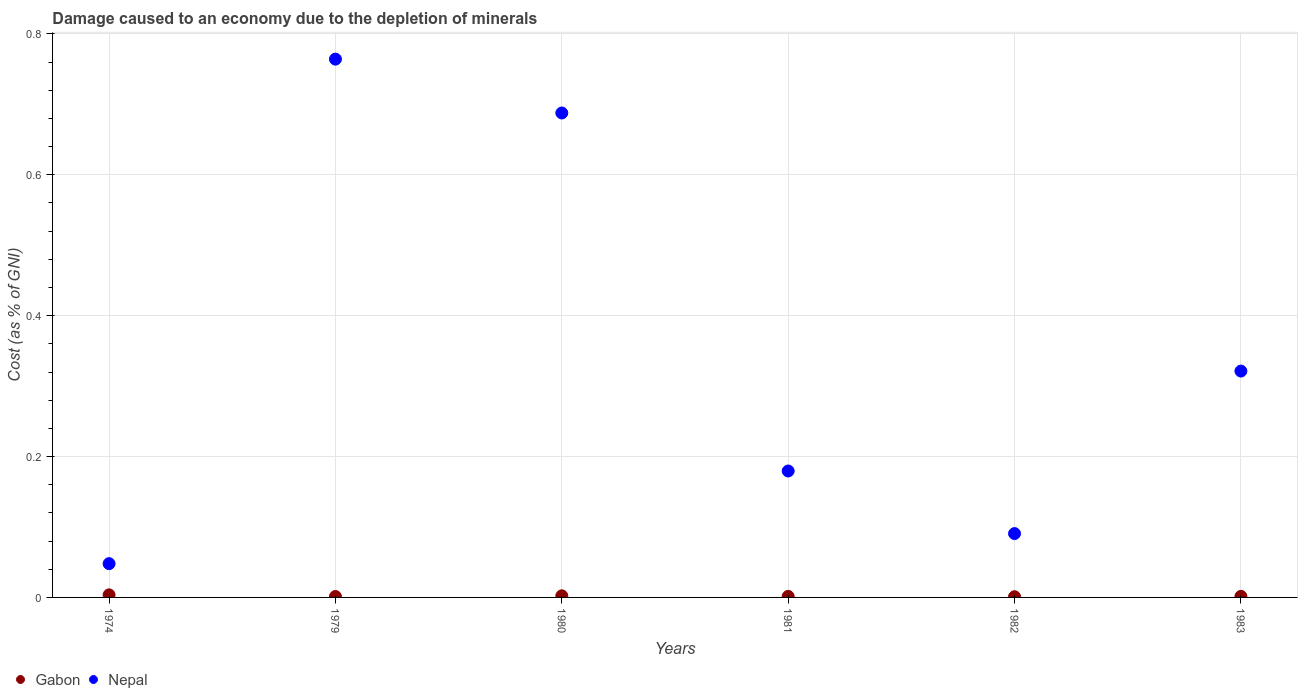How many different coloured dotlines are there?
Your answer should be very brief. 2. Is the number of dotlines equal to the number of legend labels?
Your response must be concise. Yes. What is the cost of damage caused due to the depletion of minerals in Gabon in 1980?
Provide a short and direct response. 0. Across all years, what is the maximum cost of damage caused due to the depletion of minerals in Nepal?
Give a very brief answer. 0.76. Across all years, what is the minimum cost of damage caused due to the depletion of minerals in Nepal?
Your answer should be compact. 0.05. In which year was the cost of damage caused due to the depletion of minerals in Nepal maximum?
Offer a terse response. 1979. In which year was the cost of damage caused due to the depletion of minerals in Nepal minimum?
Keep it short and to the point. 1974. What is the total cost of damage caused due to the depletion of minerals in Gabon in the graph?
Keep it short and to the point. 0.01. What is the difference between the cost of damage caused due to the depletion of minerals in Nepal in 1982 and that in 1983?
Make the answer very short. -0.23. What is the difference between the cost of damage caused due to the depletion of minerals in Gabon in 1981 and the cost of damage caused due to the depletion of minerals in Nepal in 1980?
Keep it short and to the point. -0.69. What is the average cost of damage caused due to the depletion of minerals in Nepal per year?
Keep it short and to the point. 0.35. In the year 1974, what is the difference between the cost of damage caused due to the depletion of minerals in Nepal and cost of damage caused due to the depletion of minerals in Gabon?
Your answer should be compact. 0.04. In how many years, is the cost of damage caused due to the depletion of minerals in Gabon greater than 0.7600000000000001 %?
Provide a succinct answer. 0. What is the ratio of the cost of damage caused due to the depletion of minerals in Nepal in 1974 to that in 1981?
Offer a very short reply. 0.27. Is the cost of damage caused due to the depletion of minerals in Nepal in 1974 less than that in 1981?
Ensure brevity in your answer.  Yes. What is the difference between the highest and the second highest cost of damage caused due to the depletion of minerals in Nepal?
Offer a terse response. 0.08. What is the difference between the highest and the lowest cost of damage caused due to the depletion of minerals in Gabon?
Keep it short and to the point. 0. Is the sum of the cost of damage caused due to the depletion of minerals in Gabon in 1981 and 1983 greater than the maximum cost of damage caused due to the depletion of minerals in Nepal across all years?
Make the answer very short. No. Does the cost of damage caused due to the depletion of minerals in Gabon monotonically increase over the years?
Offer a very short reply. No. How many years are there in the graph?
Provide a short and direct response. 6. Does the graph contain any zero values?
Provide a succinct answer. No. How many legend labels are there?
Offer a terse response. 2. How are the legend labels stacked?
Make the answer very short. Horizontal. What is the title of the graph?
Keep it short and to the point. Damage caused to an economy due to the depletion of minerals. What is the label or title of the X-axis?
Ensure brevity in your answer.  Years. What is the label or title of the Y-axis?
Your answer should be very brief. Cost (as % of GNI). What is the Cost (as % of GNI) of Gabon in 1974?
Provide a short and direct response. 0. What is the Cost (as % of GNI) of Nepal in 1974?
Your answer should be very brief. 0.05. What is the Cost (as % of GNI) in Gabon in 1979?
Ensure brevity in your answer.  0. What is the Cost (as % of GNI) in Nepal in 1979?
Make the answer very short. 0.76. What is the Cost (as % of GNI) in Gabon in 1980?
Provide a succinct answer. 0. What is the Cost (as % of GNI) in Nepal in 1980?
Give a very brief answer. 0.69. What is the Cost (as % of GNI) of Gabon in 1981?
Make the answer very short. 0. What is the Cost (as % of GNI) in Nepal in 1981?
Offer a very short reply. 0.18. What is the Cost (as % of GNI) of Gabon in 1982?
Make the answer very short. 0. What is the Cost (as % of GNI) in Nepal in 1982?
Your answer should be very brief. 0.09. What is the Cost (as % of GNI) in Gabon in 1983?
Your response must be concise. 0. What is the Cost (as % of GNI) of Nepal in 1983?
Make the answer very short. 0.32. Across all years, what is the maximum Cost (as % of GNI) in Gabon?
Your response must be concise. 0. Across all years, what is the maximum Cost (as % of GNI) of Nepal?
Make the answer very short. 0.76. Across all years, what is the minimum Cost (as % of GNI) in Gabon?
Your answer should be very brief. 0. Across all years, what is the minimum Cost (as % of GNI) of Nepal?
Offer a terse response. 0.05. What is the total Cost (as % of GNI) in Gabon in the graph?
Provide a short and direct response. 0.01. What is the total Cost (as % of GNI) of Nepal in the graph?
Provide a short and direct response. 2.09. What is the difference between the Cost (as % of GNI) in Gabon in 1974 and that in 1979?
Offer a terse response. 0. What is the difference between the Cost (as % of GNI) of Nepal in 1974 and that in 1979?
Your answer should be very brief. -0.72. What is the difference between the Cost (as % of GNI) of Gabon in 1974 and that in 1980?
Make the answer very short. 0. What is the difference between the Cost (as % of GNI) of Nepal in 1974 and that in 1980?
Keep it short and to the point. -0.64. What is the difference between the Cost (as % of GNI) of Gabon in 1974 and that in 1981?
Your response must be concise. 0. What is the difference between the Cost (as % of GNI) of Nepal in 1974 and that in 1981?
Your answer should be very brief. -0.13. What is the difference between the Cost (as % of GNI) in Gabon in 1974 and that in 1982?
Your response must be concise. 0. What is the difference between the Cost (as % of GNI) in Nepal in 1974 and that in 1982?
Make the answer very short. -0.04. What is the difference between the Cost (as % of GNI) of Gabon in 1974 and that in 1983?
Your answer should be very brief. 0. What is the difference between the Cost (as % of GNI) in Nepal in 1974 and that in 1983?
Keep it short and to the point. -0.27. What is the difference between the Cost (as % of GNI) of Gabon in 1979 and that in 1980?
Give a very brief answer. -0. What is the difference between the Cost (as % of GNI) in Nepal in 1979 and that in 1980?
Your answer should be very brief. 0.08. What is the difference between the Cost (as % of GNI) in Gabon in 1979 and that in 1981?
Make the answer very short. -0. What is the difference between the Cost (as % of GNI) in Nepal in 1979 and that in 1981?
Your response must be concise. 0.58. What is the difference between the Cost (as % of GNI) in Nepal in 1979 and that in 1982?
Ensure brevity in your answer.  0.67. What is the difference between the Cost (as % of GNI) of Gabon in 1979 and that in 1983?
Give a very brief answer. -0. What is the difference between the Cost (as % of GNI) of Nepal in 1979 and that in 1983?
Provide a succinct answer. 0.44. What is the difference between the Cost (as % of GNI) of Gabon in 1980 and that in 1981?
Ensure brevity in your answer.  0. What is the difference between the Cost (as % of GNI) in Nepal in 1980 and that in 1981?
Give a very brief answer. 0.51. What is the difference between the Cost (as % of GNI) in Gabon in 1980 and that in 1982?
Your answer should be very brief. 0. What is the difference between the Cost (as % of GNI) of Nepal in 1980 and that in 1982?
Keep it short and to the point. 0.6. What is the difference between the Cost (as % of GNI) of Gabon in 1980 and that in 1983?
Make the answer very short. 0. What is the difference between the Cost (as % of GNI) in Nepal in 1980 and that in 1983?
Provide a succinct answer. 0.37. What is the difference between the Cost (as % of GNI) in Nepal in 1981 and that in 1982?
Offer a terse response. 0.09. What is the difference between the Cost (as % of GNI) of Gabon in 1981 and that in 1983?
Keep it short and to the point. -0. What is the difference between the Cost (as % of GNI) in Nepal in 1981 and that in 1983?
Offer a very short reply. -0.14. What is the difference between the Cost (as % of GNI) of Gabon in 1982 and that in 1983?
Provide a succinct answer. -0. What is the difference between the Cost (as % of GNI) of Nepal in 1982 and that in 1983?
Provide a succinct answer. -0.23. What is the difference between the Cost (as % of GNI) of Gabon in 1974 and the Cost (as % of GNI) of Nepal in 1979?
Your response must be concise. -0.76. What is the difference between the Cost (as % of GNI) of Gabon in 1974 and the Cost (as % of GNI) of Nepal in 1980?
Offer a terse response. -0.68. What is the difference between the Cost (as % of GNI) of Gabon in 1974 and the Cost (as % of GNI) of Nepal in 1981?
Ensure brevity in your answer.  -0.18. What is the difference between the Cost (as % of GNI) in Gabon in 1974 and the Cost (as % of GNI) in Nepal in 1982?
Your answer should be very brief. -0.09. What is the difference between the Cost (as % of GNI) of Gabon in 1974 and the Cost (as % of GNI) of Nepal in 1983?
Give a very brief answer. -0.32. What is the difference between the Cost (as % of GNI) of Gabon in 1979 and the Cost (as % of GNI) of Nepal in 1980?
Your answer should be very brief. -0.69. What is the difference between the Cost (as % of GNI) in Gabon in 1979 and the Cost (as % of GNI) in Nepal in 1981?
Your response must be concise. -0.18. What is the difference between the Cost (as % of GNI) of Gabon in 1979 and the Cost (as % of GNI) of Nepal in 1982?
Provide a succinct answer. -0.09. What is the difference between the Cost (as % of GNI) of Gabon in 1979 and the Cost (as % of GNI) of Nepal in 1983?
Offer a terse response. -0.32. What is the difference between the Cost (as % of GNI) in Gabon in 1980 and the Cost (as % of GNI) in Nepal in 1981?
Your answer should be very brief. -0.18. What is the difference between the Cost (as % of GNI) in Gabon in 1980 and the Cost (as % of GNI) in Nepal in 1982?
Provide a succinct answer. -0.09. What is the difference between the Cost (as % of GNI) of Gabon in 1980 and the Cost (as % of GNI) of Nepal in 1983?
Provide a short and direct response. -0.32. What is the difference between the Cost (as % of GNI) in Gabon in 1981 and the Cost (as % of GNI) in Nepal in 1982?
Provide a succinct answer. -0.09. What is the difference between the Cost (as % of GNI) of Gabon in 1981 and the Cost (as % of GNI) of Nepal in 1983?
Offer a terse response. -0.32. What is the difference between the Cost (as % of GNI) of Gabon in 1982 and the Cost (as % of GNI) of Nepal in 1983?
Offer a terse response. -0.32. What is the average Cost (as % of GNI) in Gabon per year?
Your answer should be compact. 0. What is the average Cost (as % of GNI) of Nepal per year?
Your answer should be very brief. 0.35. In the year 1974, what is the difference between the Cost (as % of GNI) in Gabon and Cost (as % of GNI) in Nepal?
Offer a terse response. -0.04. In the year 1979, what is the difference between the Cost (as % of GNI) of Gabon and Cost (as % of GNI) of Nepal?
Offer a terse response. -0.76. In the year 1980, what is the difference between the Cost (as % of GNI) in Gabon and Cost (as % of GNI) in Nepal?
Your response must be concise. -0.69. In the year 1981, what is the difference between the Cost (as % of GNI) of Gabon and Cost (as % of GNI) of Nepal?
Make the answer very short. -0.18. In the year 1982, what is the difference between the Cost (as % of GNI) of Gabon and Cost (as % of GNI) of Nepal?
Provide a succinct answer. -0.09. In the year 1983, what is the difference between the Cost (as % of GNI) of Gabon and Cost (as % of GNI) of Nepal?
Your answer should be compact. -0.32. What is the ratio of the Cost (as % of GNI) of Gabon in 1974 to that in 1979?
Make the answer very short. 2.8. What is the ratio of the Cost (as % of GNI) of Nepal in 1974 to that in 1979?
Provide a succinct answer. 0.06. What is the ratio of the Cost (as % of GNI) of Gabon in 1974 to that in 1980?
Ensure brevity in your answer.  1.6. What is the ratio of the Cost (as % of GNI) of Nepal in 1974 to that in 1980?
Offer a terse response. 0.07. What is the ratio of the Cost (as % of GNI) of Gabon in 1974 to that in 1981?
Provide a succinct answer. 2.5. What is the ratio of the Cost (as % of GNI) of Nepal in 1974 to that in 1981?
Make the answer very short. 0.27. What is the ratio of the Cost (as % of GNI) of Gabon in 1974 to that in 1982?
Provide a succinct answer. 3.67. What is the ratio of the Cost (as % of GNI) of Nepal in 1974 to that in 1982?
Provide a short and direct response. 0.53. What is the ratio of the Cost (as % of GNI) of Gabon in 1974 to that in 1983?
Your response must be concise. 2.46. What is the ratio of the Cost (as % of GNI) in Nepal in 1974 to that in 1983?
Give a very brief answer. 0.15. What is the ratio of the Cost (as % of GNI) of Gabon in 1979 to that in 1980?
Offer a very short reply. 0.57. What is the ratio of the Cost (as % of GNI) in Gabon in 1979 to that in 1981?
Provide a succinct answer. 0.89. What is the ratio of the Cost (as % of GNI) in Nepal in 1979 to that in 1981?
Provide a short and direct response. 4.26. What is the ratio of the Cost (as % of GNI) in Gabon in 1979 to that in 1982?
Offer a terse response. 1.31. What is the ratio of the Cost (as % of GNI) of Nepal in 1979 to that in 1982?
Make the answer very short. 8.43. What is the ratio of the Cost (as % of GNI) of Gabon in 1979 to that in 1983?
Offer a terse response. 0.88. What is the ratio of the Cost (as % of GNI) in Nepal in 1979 to that in 1983?
Your response must be concise. 2.38. What is the ratio of the Cost (as % of GNI) of Gabon in 1980 to that in 1981?
Keep it short and to the point. 1.56. What is the ratio of the Cost (as % of GNI) of Nepal in 1980 to that in 1981?
Your answer should be compact. 3.83. What is the ratio of the Cost (as % of GNI) of Gabon in 1980 to that in 1982?
Your response must be concise. 2.29. What is the ratio of the Cost (as % of GNI) of Nepal in 1980 to that in 1982?
Provide a short and direct response. 7.59. What is the ratio of the Cost (as % of GNI) of Gabon in 1980 to that in 1983?
Make the answer very short. 1.54. What is the ratio of the Cost (as % of GNI) of Nepal in 1980 to that in 1983?
Offer a very short reply. 2.14. What is the ratio of the Cost (as % of GNI) of Gabon in 1981 to that in 1982?
Make the answer very short. 1.47. What is the ratio of the Cost (as % of GNI) in Nepal in 1981 to that in 1982?
Provide a short and direct response. 1.98. What is the ratio of the Cost (as % of GNI) of Gabon in 1981 to that in 1983?
Your answer should be very brief. 0.99. What is the ratio of the Cost (as % of GNI) in Nepal in 1981 to that in 1983?
Ensure brevity in your answer.  0.56. What is the ratio of the Cost (as % of GNI) of Gabon in 1982 to that in 1983?
Your response must be concise. 0.67. What is the ratio of the Cost (as % of GNI) in Nepal in 1982 to that in 1983?
Provide a short and direct response. 0.28. What is the difference between the highest and the second highest Cost (as % of GNI) in Gabon?
Your answer should be compact. 0. What is the difference between the highest and the second highest Cost (as % of GNI) of Nepal?
Your answer should be very brief. 0.08. What is the difference between the highest and the lowest Cost (as % of GNI) of Gabon?
Provide a short and direct response. 0. What is the difference between the highest and the lowest Cost (as % of GNI) in Nepal?
Provide a short and direct response. 0.72. 